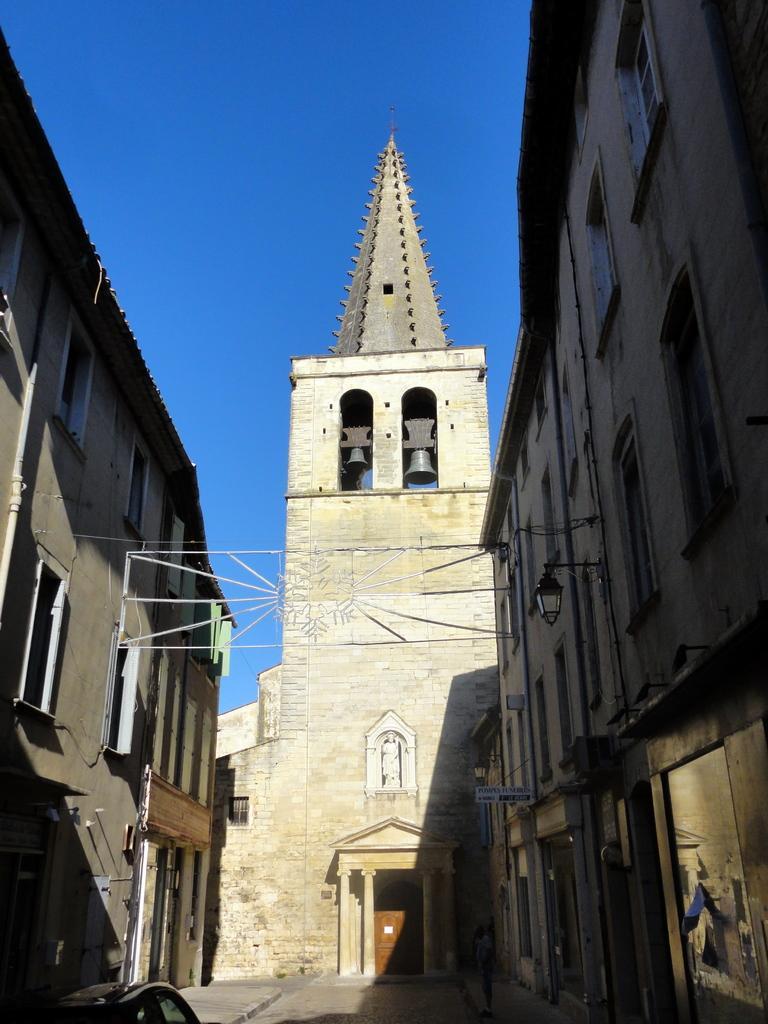Can you describe this image briefly? In this picture there are buildings. There are bells and there is a sculpture and board on the buildings. At the bottom left there is a car on the road. At the top there is sky. 